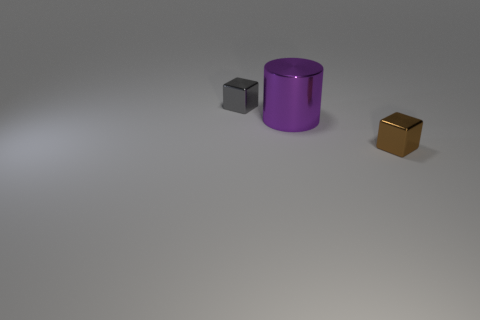Add 2 big purple metal cylinders. How many objects exist? 5 Subtract all cylinders. How many objects are left? 2 Subtract all metallic objects. Subtract all red rubber blocks. How many objects are left? 0 Add 3 big purple metallic cylinders. How many big purple metallic cylinders are left? 4 Add 1 tiny gray things. How many tiny gray things exist? 2 Subtract 0 purple balls. How many objects are left? 3 